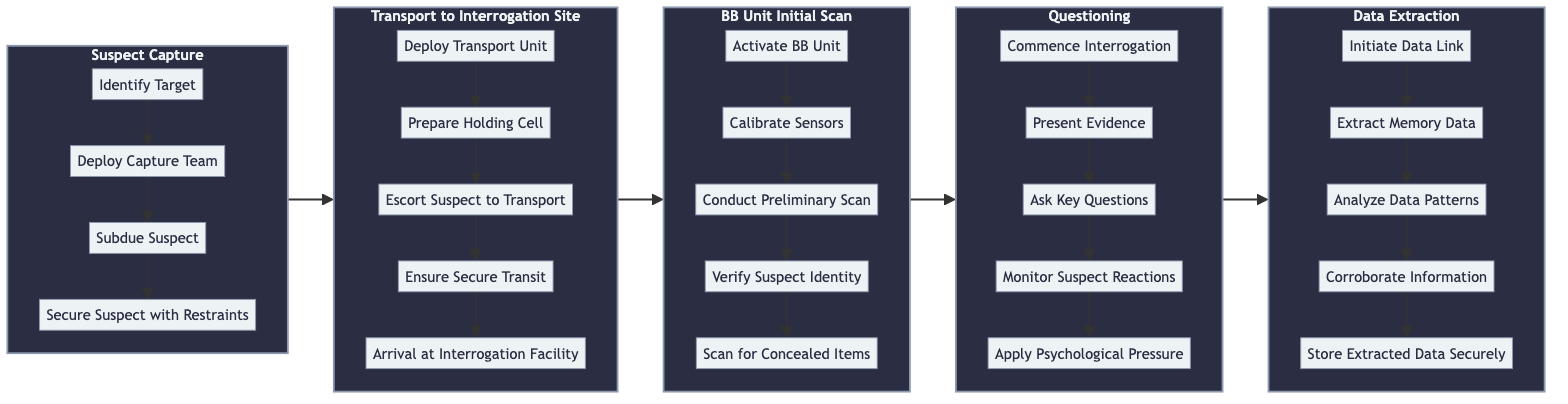What is the first step in the Suspect Capture stage? The first step in the Suspect Capture stage is "Identify Target," as indicated at the beginning of that segment in the flowchart.
Answer: Identify Target How many steps are there in the Data Extraction stage? The Data Extraction stage contains five steps as shown in the diagram, each labeled sequentially from DE1 to DE5.
Answer: 5 What step follows "Commence Interrogation"? According to the flowchart, "Present Evidence" directly follows "Commence Interrogation" in the Questioning stage.
Answer: Present Evidence Which stage comes after the Transport to Interrogation Site? The flowchart shows that BB Unit Initial Scan is the subsequent stage that follows after Transport to Interrogation Site.
Answer: BB Unit Initial Scan What is the last step in the BB Unit Initial Scan? The final step in the BB Unit Initial Scan stage is "Scan for Concealed Items," as listed last in that segment of the flowchart.
Answer: Scan for Concealed Items How many stages are present in the entire interrogation procedure? There are five distinct stages outlined in the interrogation procedure: Suspect Capture, Transport to Interrogation Site, BB Unit Initial Scan, Questioning, and Data Extraction, marking a total of five stages.
Answer: 5 What step concludes the entire interrogation procedure? The last step in the interrogation procedure is "Store Extracted Data Securely," which is the final step listed in the Data Extraction stage.
Answer: Store Extracted Data Securely Which step requires the BB Unit to be activated? The step that requires the BB Unit to be activated is "Activate BB Unit," which is the first step in the BB Unit Initial Scan stage.
Answer: Activate BB Unit What is the relationship between the First and Second stages? The relationship is such that the Transport to Interrogation Site stage directly follows the Suspect Capture stage, indicating a sequential flow between these two stages.
Answer: Sequential 